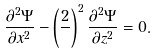<formula> <loc_0><loc_0><loc_500><loc_500>\frac { \partial ^ { 2 } \Psi } { \partial x ^ { 2 } } - \left ( \frac { 2 } { } \right ) ^ { 2 } \frac { \partial ^ { 2 } \Psi } { \partial z ^ { 2 } } = 0 .</formula> 